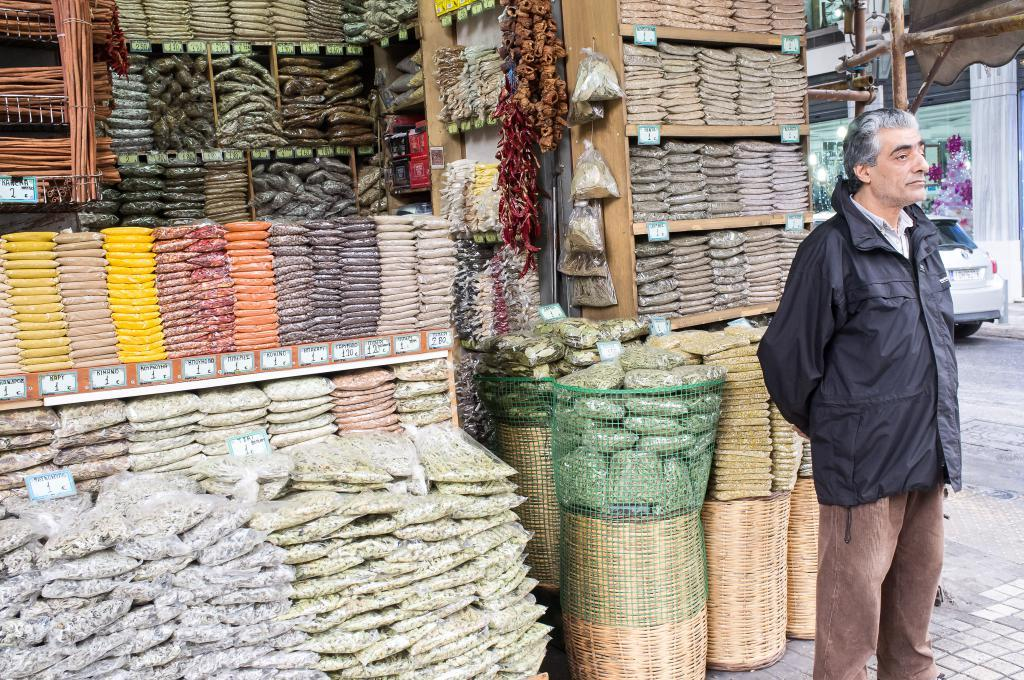What is the main subject in the middle of the image? There is a man standing in the middle of the image. What is located behind the man? There is a store behind the man. What can be seen on the store? There are packets on the store. What else is present in the image? There is a vehicle in the image. Can you see a crown on the man's head in the image? There is no crown visible on the man's head in the image. What type of drain is present near the vehicle in the image? There is no drain present in the image; it only features a man, a store, packets, and a vehicle. 